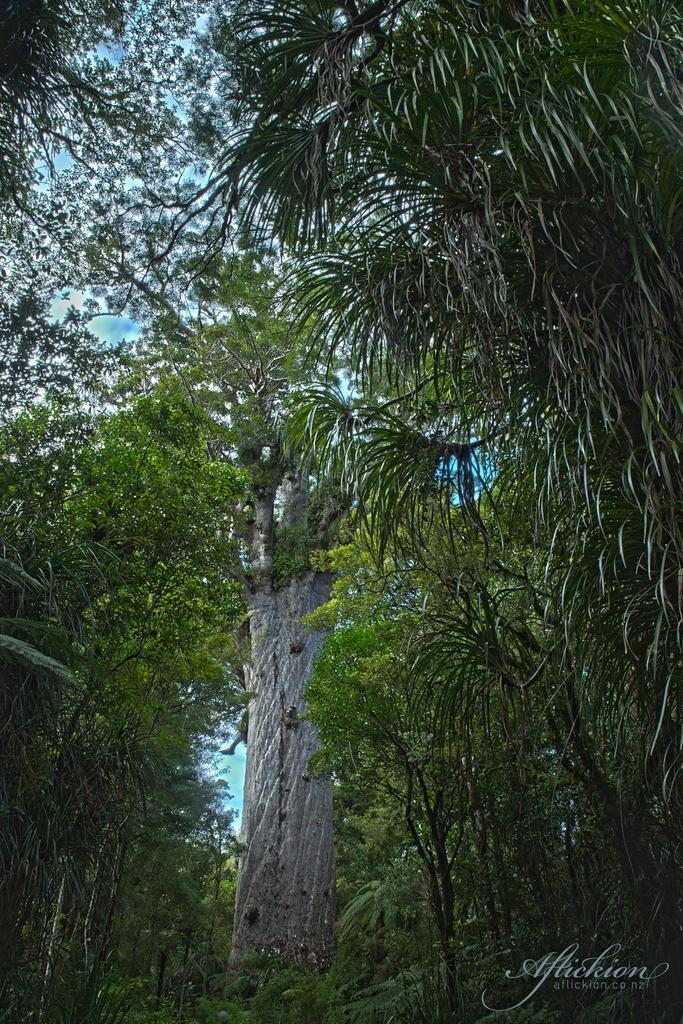What can be seen at the top of the image? The sky is visible in the image. What type of vegetation is present in the image? There are trees in the image. Is there any text or marking in the image? Yes, there is a watermark in the bottom right corner of the image. What language is the ant speaking in the image? There is no ant present in the image, so it is not possible to determine what language it might be speaking. 